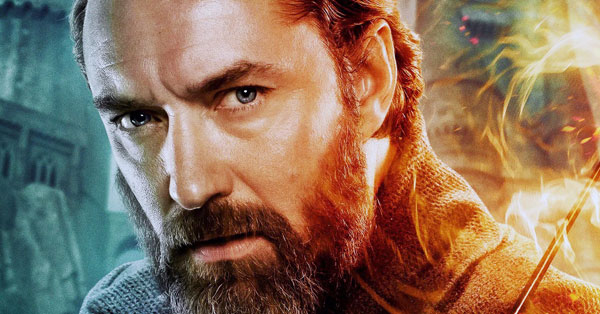Create a backstory for this character. This character, Arion Eldrake, is a master sorcerer and the last heir to the ancient, magical Eldrake lineage. Raised in the secluded mountains of Eldor, Arion was trained from a young age in the arcane arts by his grandmother, the most powerful sorceress of her time. After her untimely death in a battle against dark forces, Arion swore to protect their realm against future threats. His journey has been long and arduous, filled with battles, alliances, and the ever-present challenge of controlling the immense power within him. Arion is now on the brink of a monumental conflict that will determine the fate of his world. Describe a casual day in Arion Eldrake's life. On a rare peaceful day, Arion Eldrake begins his morning with meditation on the terrace of his family castle, overlooking the majestic Eldor Mountains. He spends a few hours studying ancient texts in his library, deciphering forgotten spells and lore. In the afternoon, he tends to his magical garden, where rare herbs and plants flourish under his care. He might pay a visit to the nearby village, offering counsel and help to its people. The evening is reserved for training young apprentices, passing on his vast knowledge to the next generation of sorcerers. As the sun sets, Arion enjoys a quiet dinner with close friends or family, reflecting on the day's learnings before retreating to his chambers to plan for the challenges ahead. 